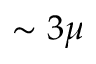Convert formula to latex. <formula><loc_0><loc_0><loc_500><loc_500>\sim 3 \mu</formula> 